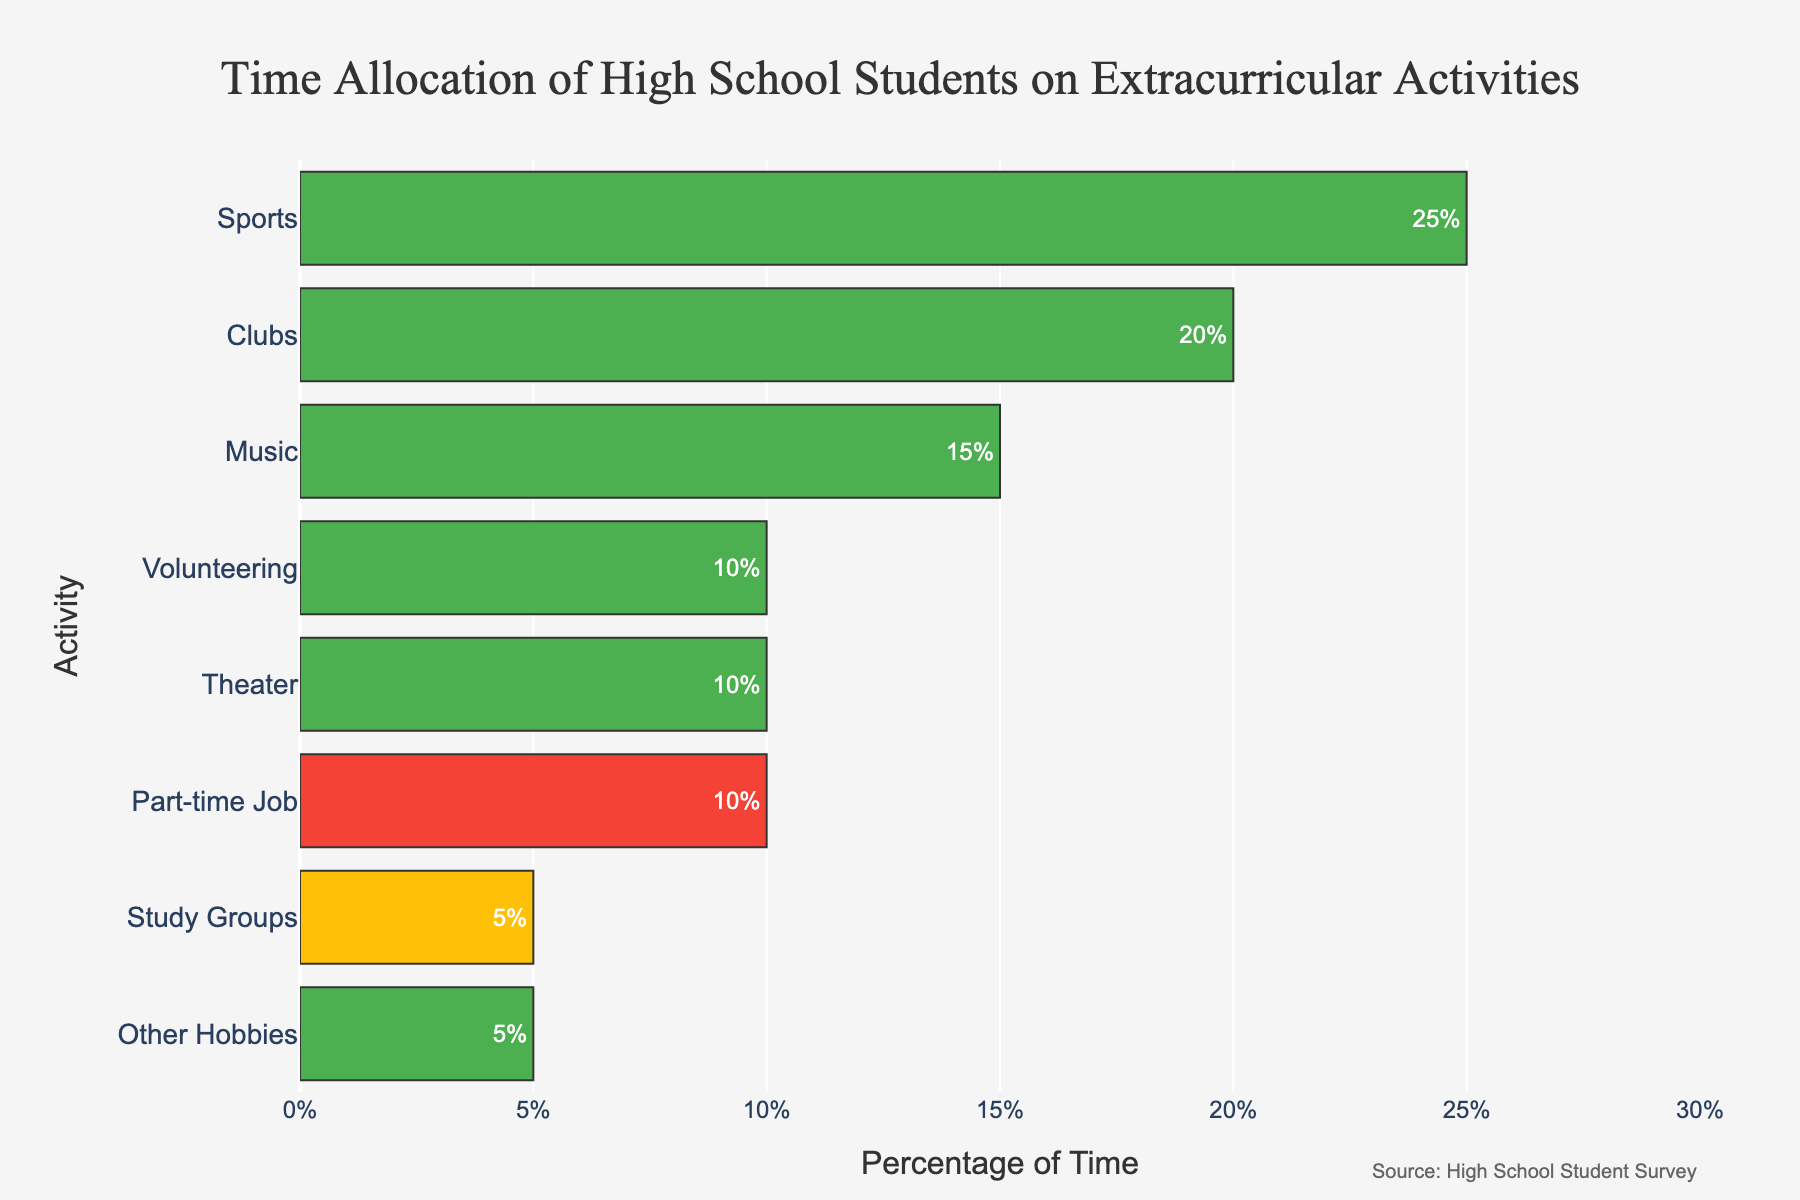What is the total percentage of time students spend on positive extracurricular activities? First, identify all activities categorized as 'Positive': Sports (25%), Clubs (20%), Music (15%), Volunteering (10%), Theater (10%), Other Hobbies (5%). Sum these percentages: 25% + 20% + 15% + 10% + 10% + 5% = 85%.
Answer: 85% How much more time do students spend on sports compared to part-time jobs? Sports accounts for 25% of the time, whereas part-time jobs account for 10%. The difference is 25% - 10% = 15%.
Answer: 15% Which activity has the smallest percentage of time allocation among positive activities? The positive activities and their percentages are: Sports (25%), Clubs (20%), Music (15%), Volunteering (10%), Theater (10%), and Other Hobbies (5%). The smallest percentage is Other Hobbies at 5%.
Answer: Other Hobbies What is the ratio of time spent on clubs to the time spent on music? The percentage of time spent on clubs is 20% and on music is 15%. The ratio is 20% / 15% = 4 / 3, which simplifies to approximately 1.33.
Answer: 1.33 Do students spend more time on theater or volunteering? Both theater and volunteering have a percentage of 10%. They are equal.
Answer: Equal How does the time allocation for study groups compare to part-time jobs? Study groups have a 5% time allocation, while part-time jobs have 10%. If we compare, part-time jobs' allocation (10%) is twice that of study groups (5%).
Answer: Part-time jobs are twice that of study groups Which activity has the highest percentage of time allocation? By observing the bar lengths, Sports is the activity with the highest allocation at 25%.
Answer: Sports What is the combined percentage of time spent on activities categorized as neutral or negative? Study Groups (Neutral) is 5% and Part-time Job (Negative) is 10%. Combined: 5% + 10% = 15%.
Answer: 15% Which activities are categorized as negative? There is only one activity categorized as negative: Part-time Job at 10%.
Answer: Part-time Job 